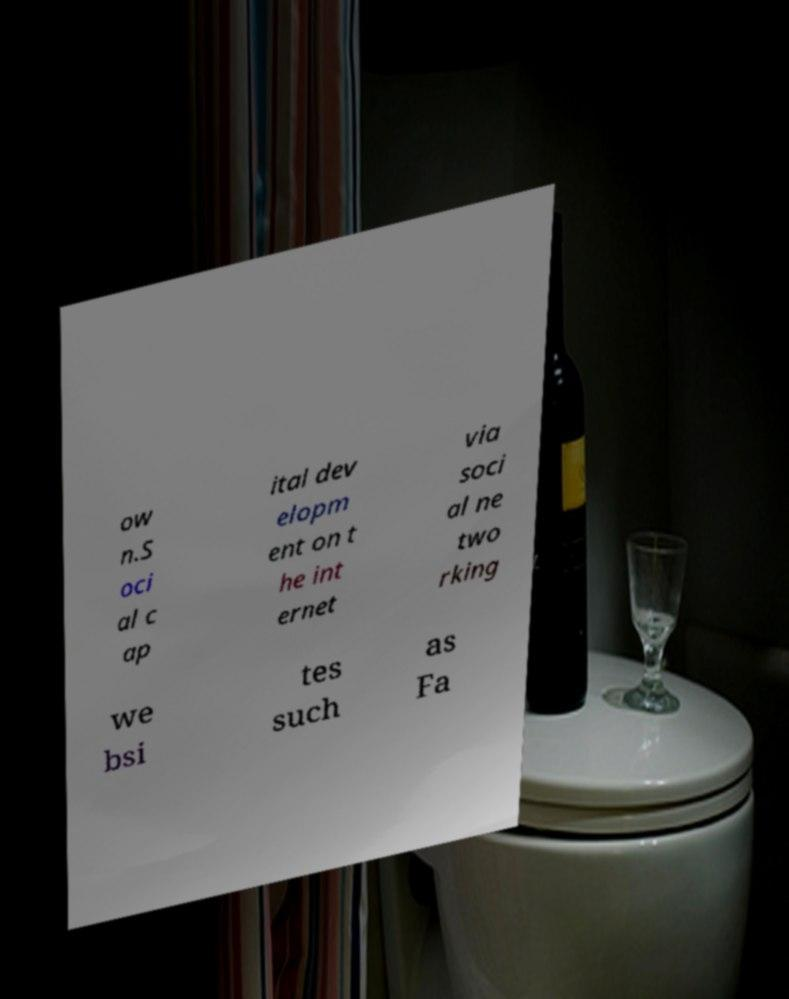Can you accurately transcribe the text from the provided image for me? ow n.S oci al c ap ital dev elopm ent on t he int ernet via soci al ne two rking we bsi tes such as Fa 